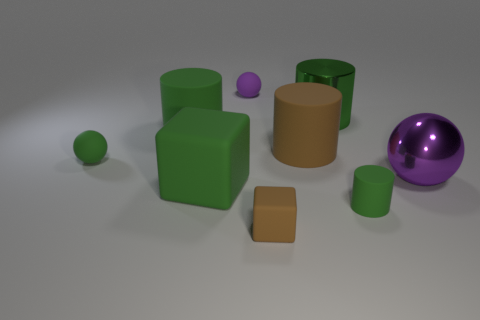There is a small green object right of the purple matte ball; what material is it? rubber 